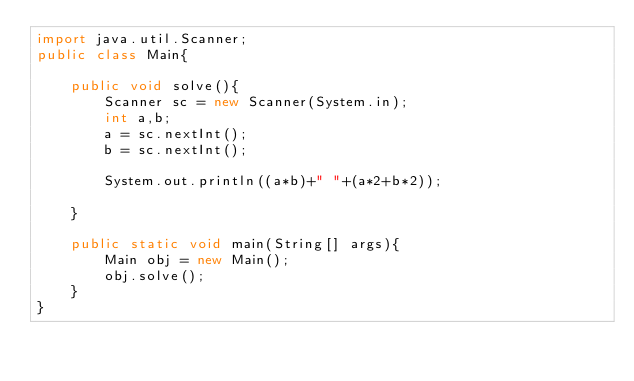<code> <loc_0><loc_0><loc_500><loc_500><_Java_>import java.util.Scanner;
public class Main{
     
    public void solve(){
        Scanner sc = new Scanner(System.in);
        int a,b;
        a = sc.nextInt();
        b = sc.nextInt();
         
        System.out.println((a*b)+" "+(a*2+b*2));
         
    }
     
    public static void main(String[] args){
        Main obj = new Main();
        obj.solve();
    }
}</code> 